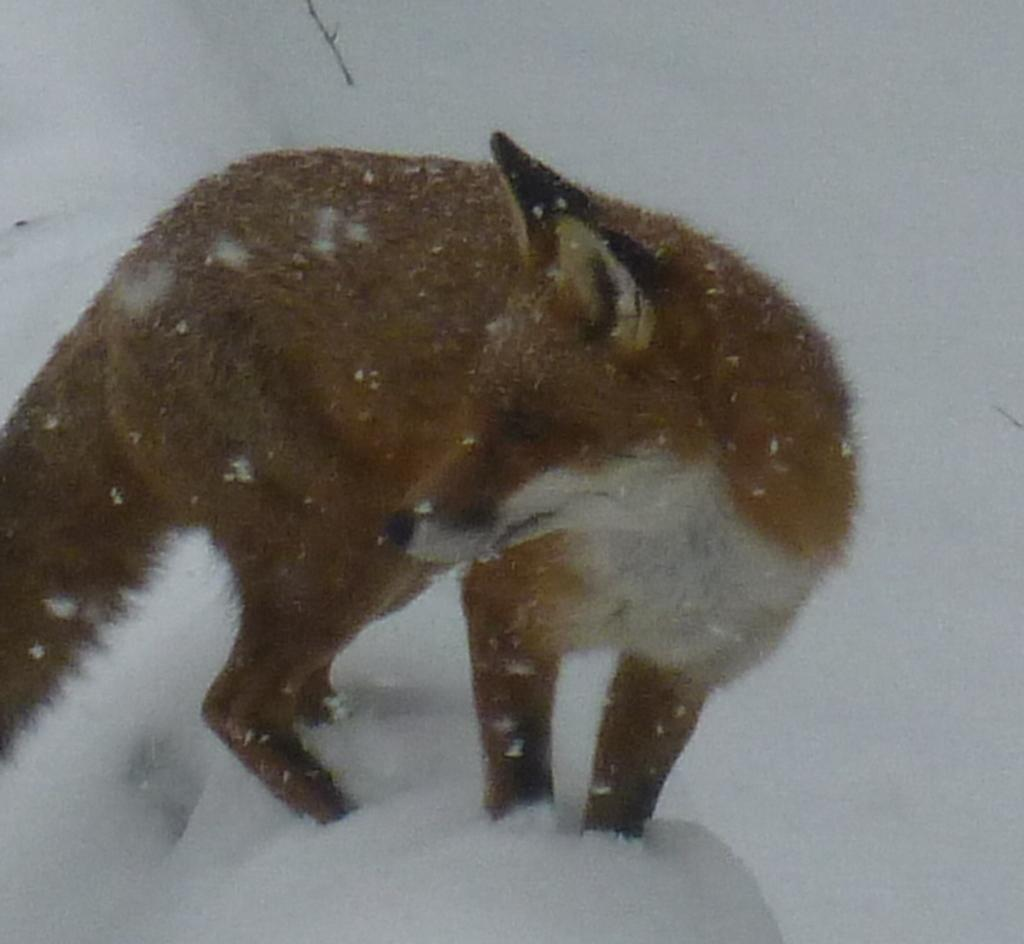What is the main subject in the center of the image? There is a fox in the center of the image. What type of environment is suggested by the background of the image? There is snow visible in the background of the image, which suggests a winter setting. What type of donkey can be seen using the fox as a sled in the image? There is no donkey present in the image, nor is the fox being used as a sled. 